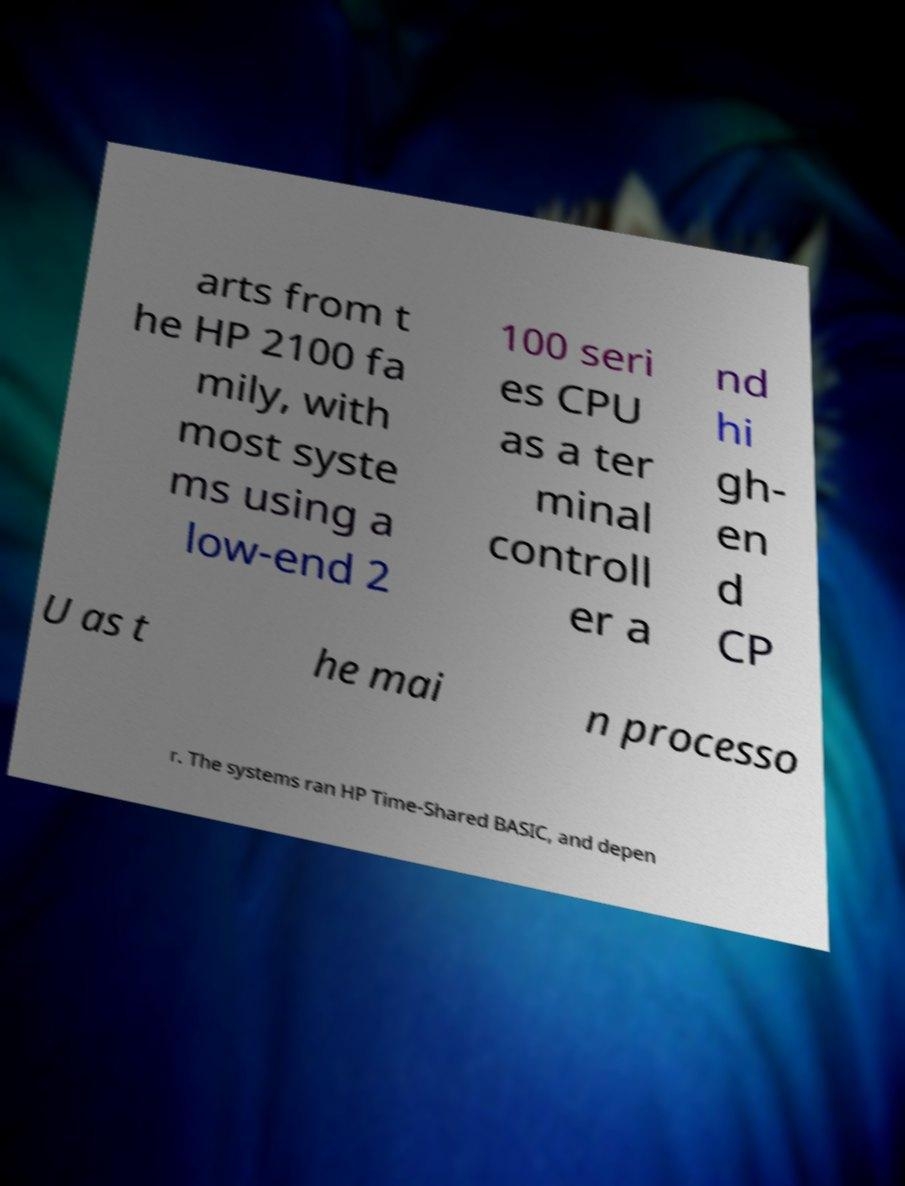I need the written content from this picture converted into text. Can you do that? arts from t he HP 2100 fa mily, with most syste ms using a low-end 2 100 seri es CPU as a ter minal controll er a nd hi gh- en d CP U as t he mai n processo r. The systems ran HP Time-Shared BASIC, and depen 